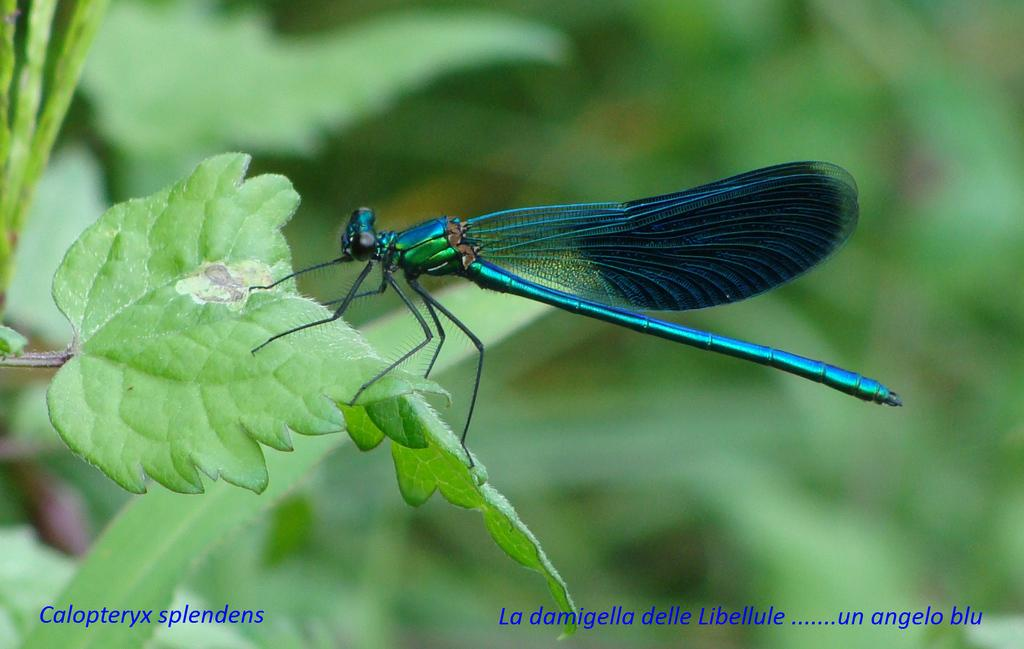What is present in the image? There is a fly in the image. Where is the fly located? The fly is standing on a leaf. How many women are playing on the playground in the image? There are no women or playground present in the image; it only features a fly standing on a leaf. 